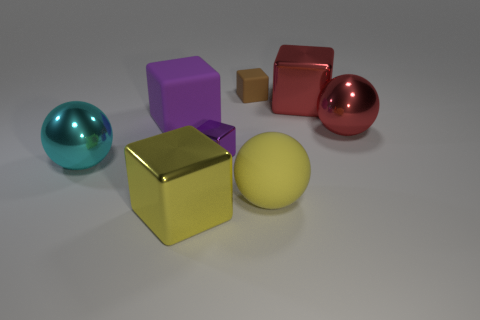Is the color of the tiny matte cube the same as the small shiny cube?
Keep it short and to the point. No. Are there fewer big cyan things than brown shiny cylinders?
Offer a very short reply. No. What number of other things are there of the same color as the small rubber thing?
Your answer should be compact. 0. What number of big purple rubber cylinders are there?
Your response must be concise. 0. Are there fewer large red shiny spheres to the left of the big purple rubber thing than small yellow metallic cylinders?
Keep it short and to the point. No. Is the material of the small thing to the left of the brown block the same as the brown block?
Ensure brevity in your answer.  No. There is a red object that is behind the purple block that is behind the big ball right of the yellow rubber ball; what is its shape?
Make the answer very short. Cube. Is there a metallic ball that has the same size as the yellow rubber sphere?
Your answer should be compact. Yes. The red shiny sphere is what size?
Ensure brevity in your answer.  Large. How many rubber cubes are the same size as the cyan metal ball?
Your response must be concise. 1. 